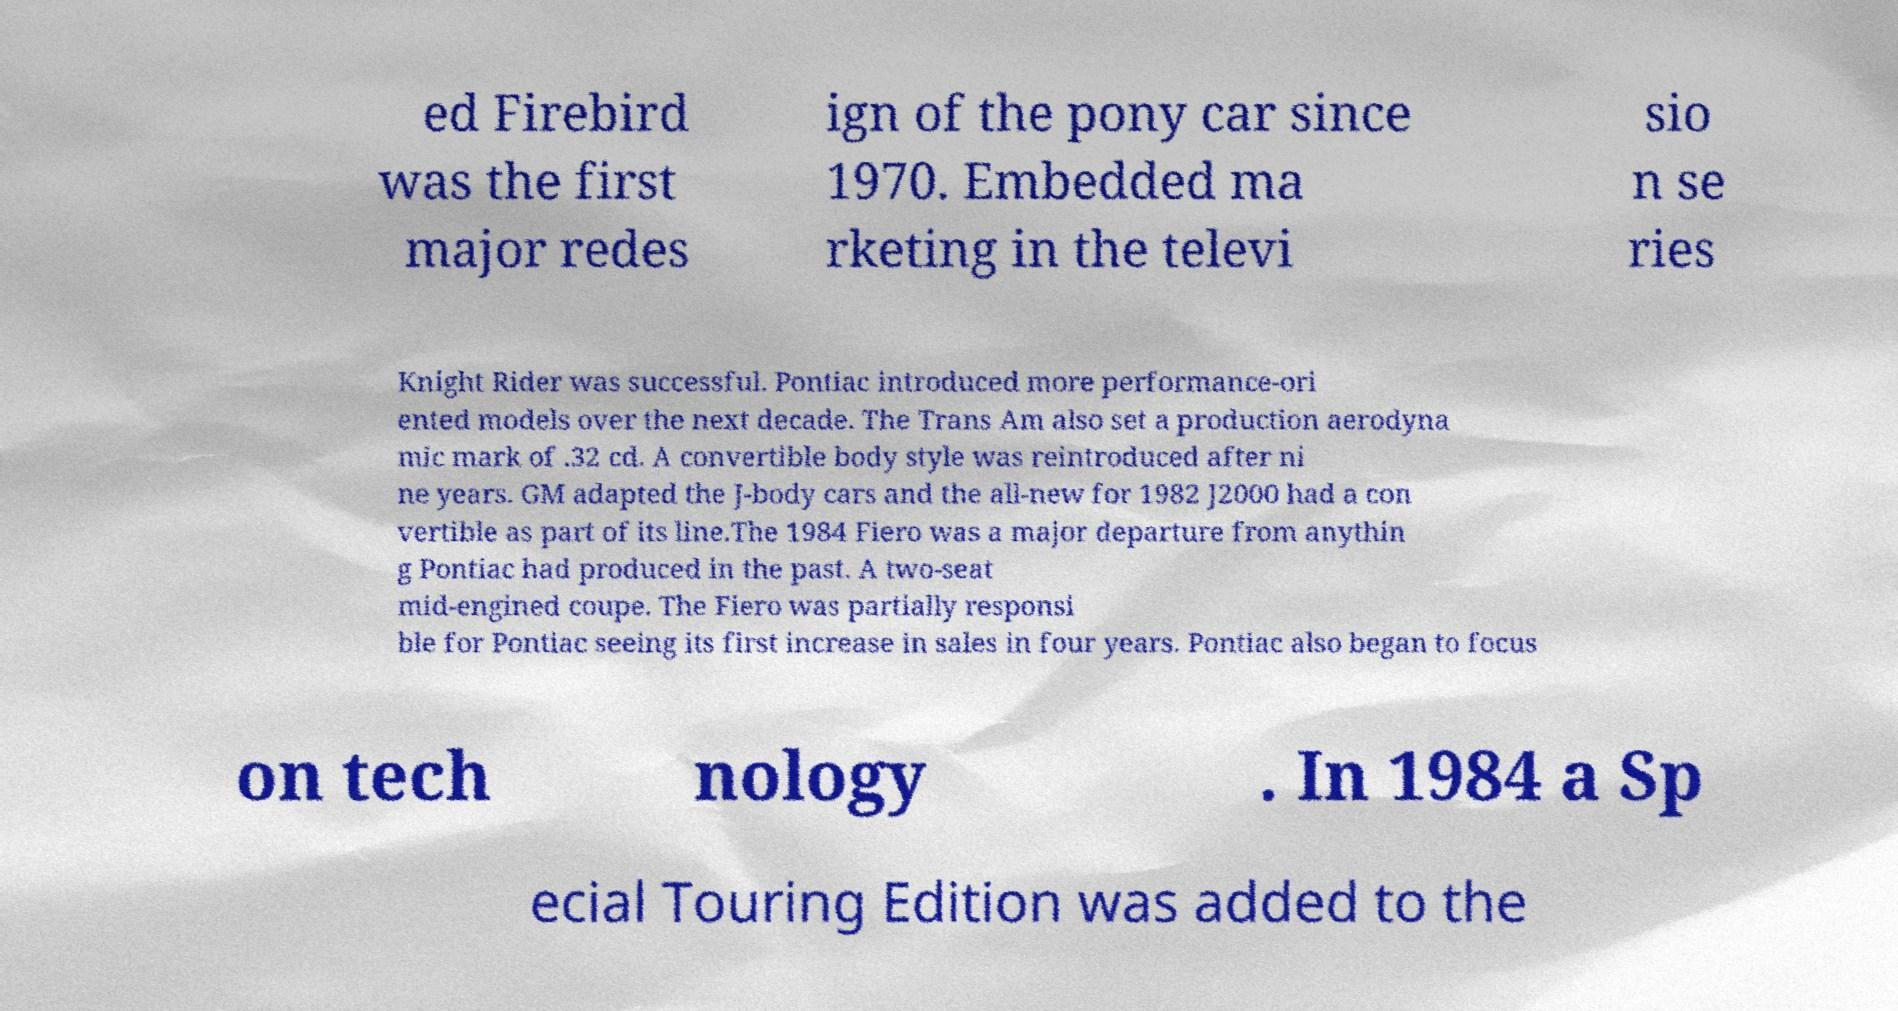Could you extract and type out the text from this image? ed Firebird was the first major redes ign of the pony car since 1970. Embedded ma rketing in the televi sio n se ries Knight Rider was successful. Pontiac introduced more performance-ori ented models over the next decade. The Trans Am also set a production aerodyna mic mark of .32 cd. A convertible body style was reintroduced after ni ne years. GM adapted the J-body cars and the all-new for 1982 J2000 had a con vertible as part of its line.The 1984 Fiero was a major departure from anythin g Pontiac had produced in the past. A two-seat mid-engined coupe. The Fiero was partially responsi ble for Pontiac seeing its first increase in sales in four years. Pontiac also began to focus on tech nology . In 1984 a Sp ecial Touring Edition was added to the 